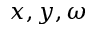Convert formula to latex. <formula><loc_0><loc_0><loc_500><loc_500>x , y , \omega</formula> 